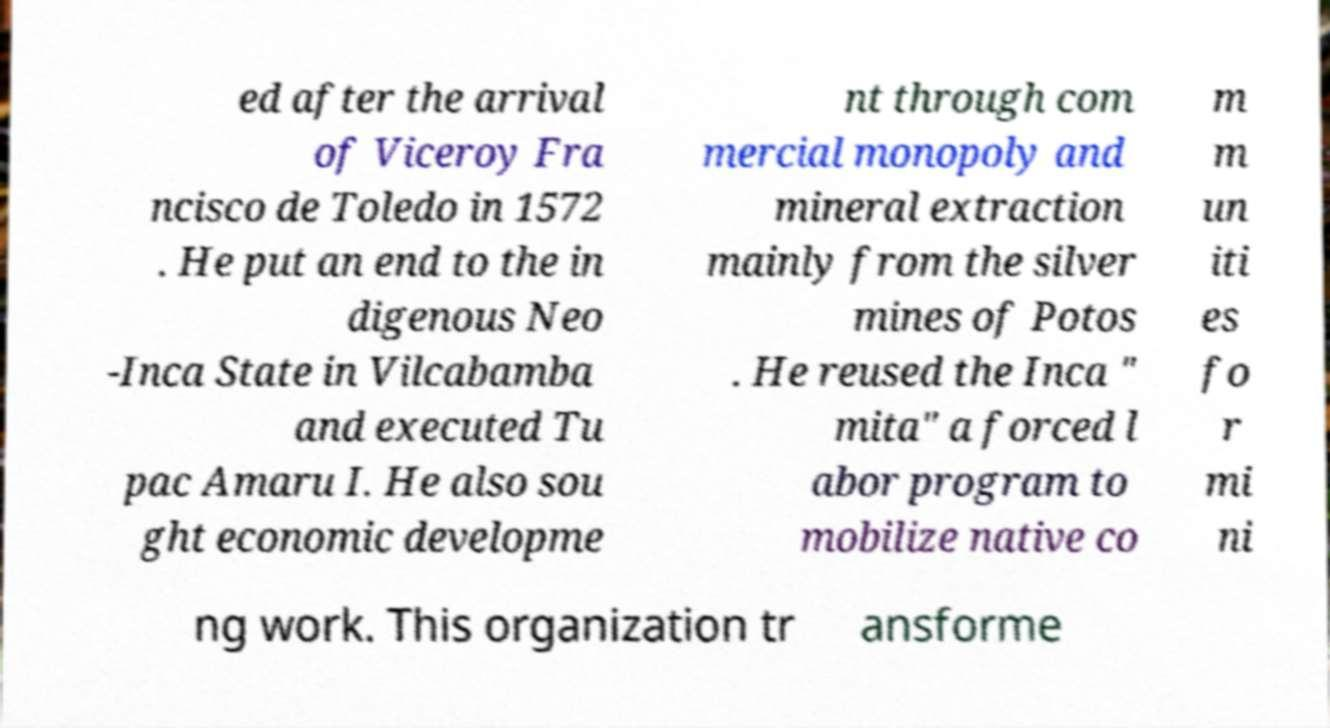Could you assist in decoding the text presented in this image and type it out clearly? ed after the arrival of Viceroy Fra ncisco de Toledo in 1572 . He put an end to the in digenous Neo -Inca State in Vilcabamba and executed Tu pac Amaru I. He also sou ght economic developme nt through com mercial monopoly and mineral extraction mainly from the silver mines of Potos . He reused the Inca " mita" a forced l abor program to mobilize native co m m un iti es fo r mi ni ng work. This organization tr ansforme 